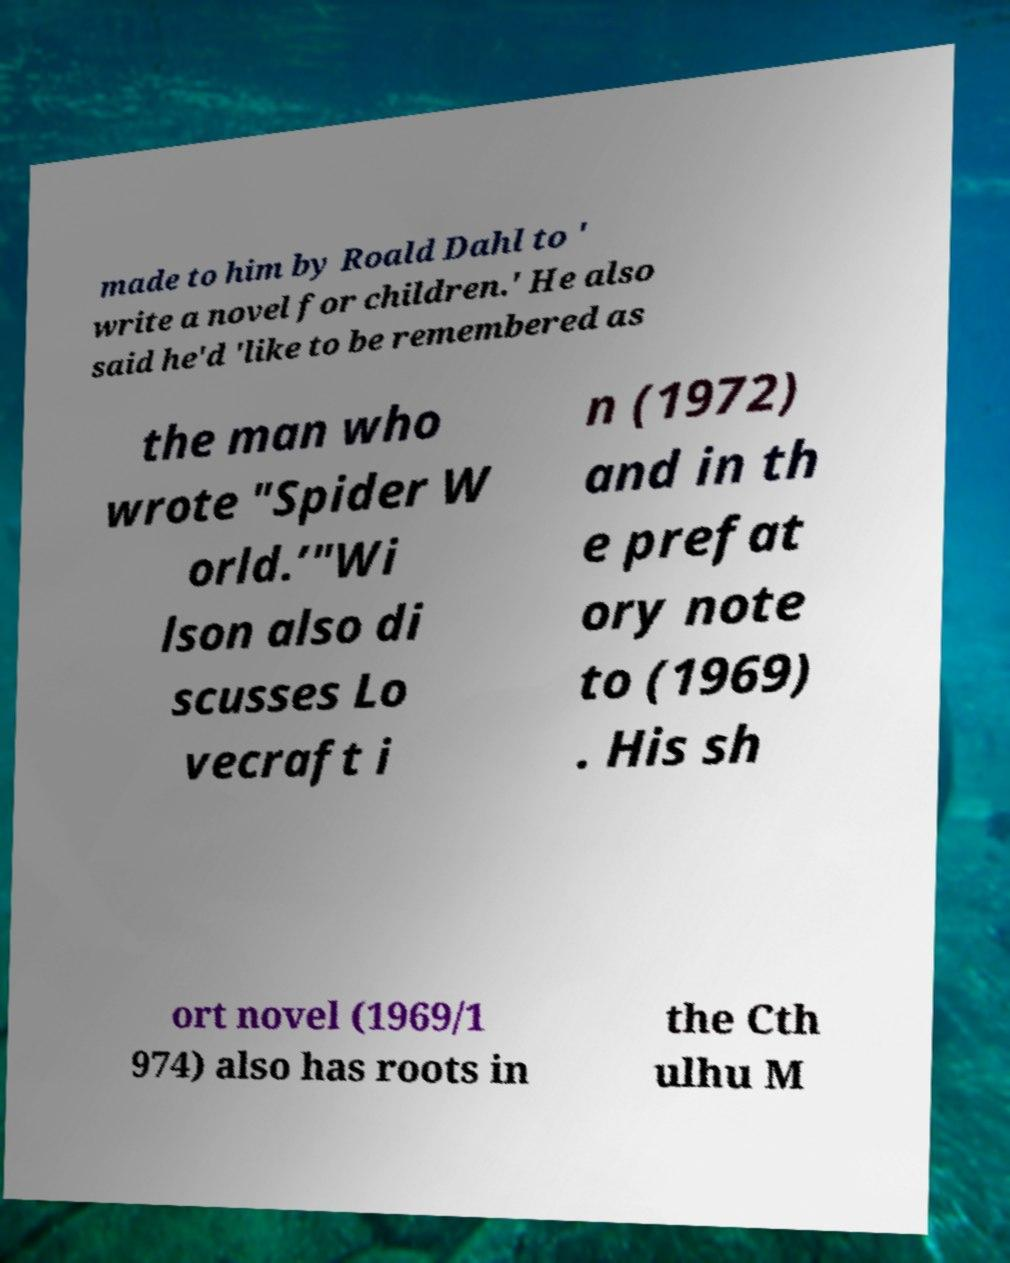I need the written content from this picture converted into text. Can you do that? made to him by Roald Dahl to ' write a novel for children.' He also said he'd 'like to be remembered as the man who wrote "Spider W orld.’"Wi lson also di scusses Lo vecraft i n (1972) and in th e prefat ory note to (1969) . His sh ort novel (1969/1 974) also has roots in the Cth ulhu M 